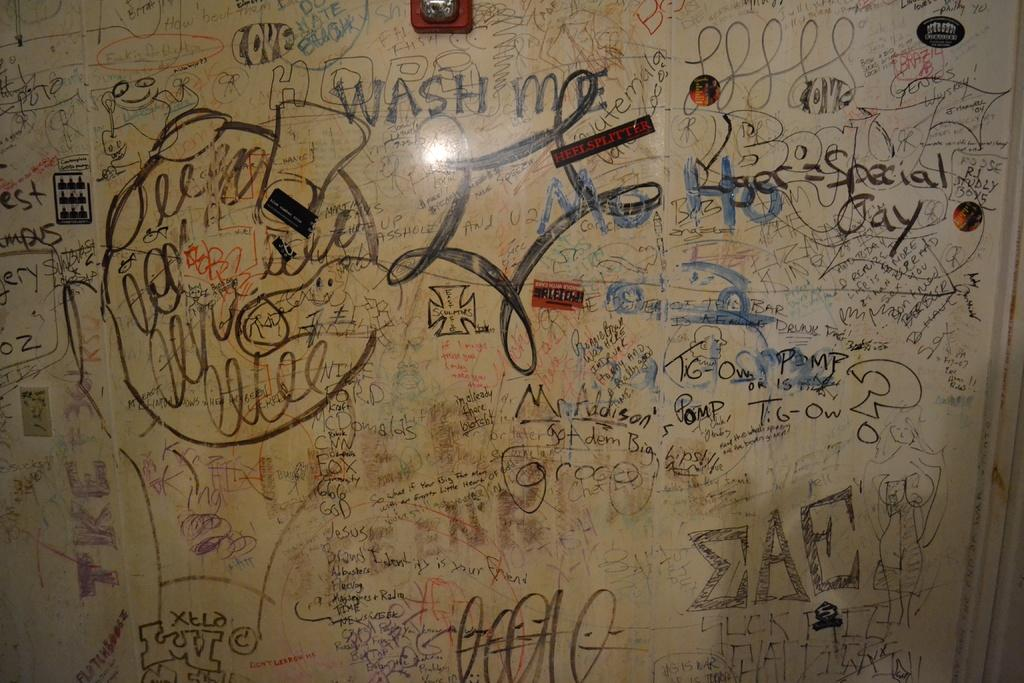Provide a one-sentence caption for the provided image. Board with random writing on it and the word "wash" in the middle. 